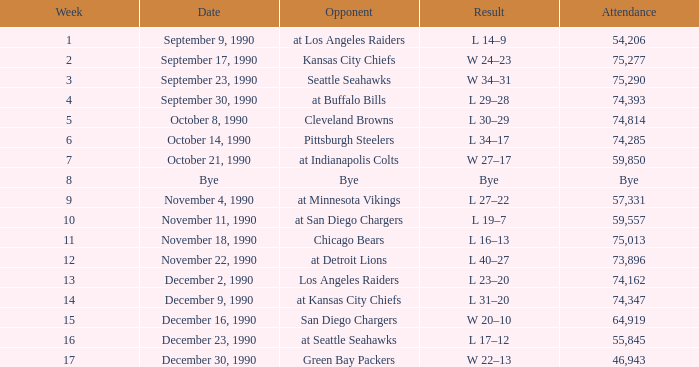Who is the opponent when the attendance is 57,331? At minnesota vikings. 